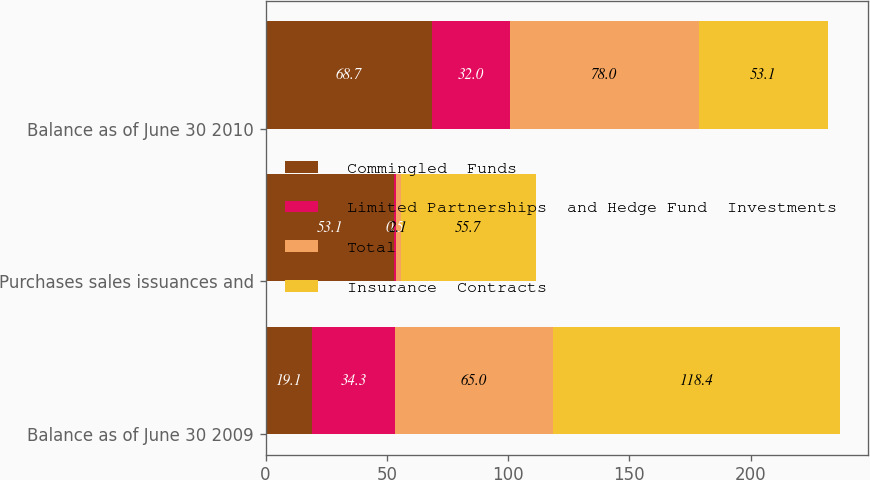<chart> <loc_0><loc_0><loc_500><loc_500><stacked_bar_chart><ecel><fcel>Balance as of June 30 2009<fcel>Purchases sales issuances and<fcel>Balance as of June 30 2010<nl><fcel>Commingled  Funds<fcel>19.1<fcel>53.1<fcel>68.7<nl><fcel>Limited Partnerships  and Hedge Fund  Investments<fcel>34.3<fcel>0.5<fcel>32<nl><fcel>Total<fcel>65<fcel>2.1<fcel>78<nl><fcel>Insurance  Contracts<fcel>118.4<fcel>55.7<fcel>53.1<nl></chart> 